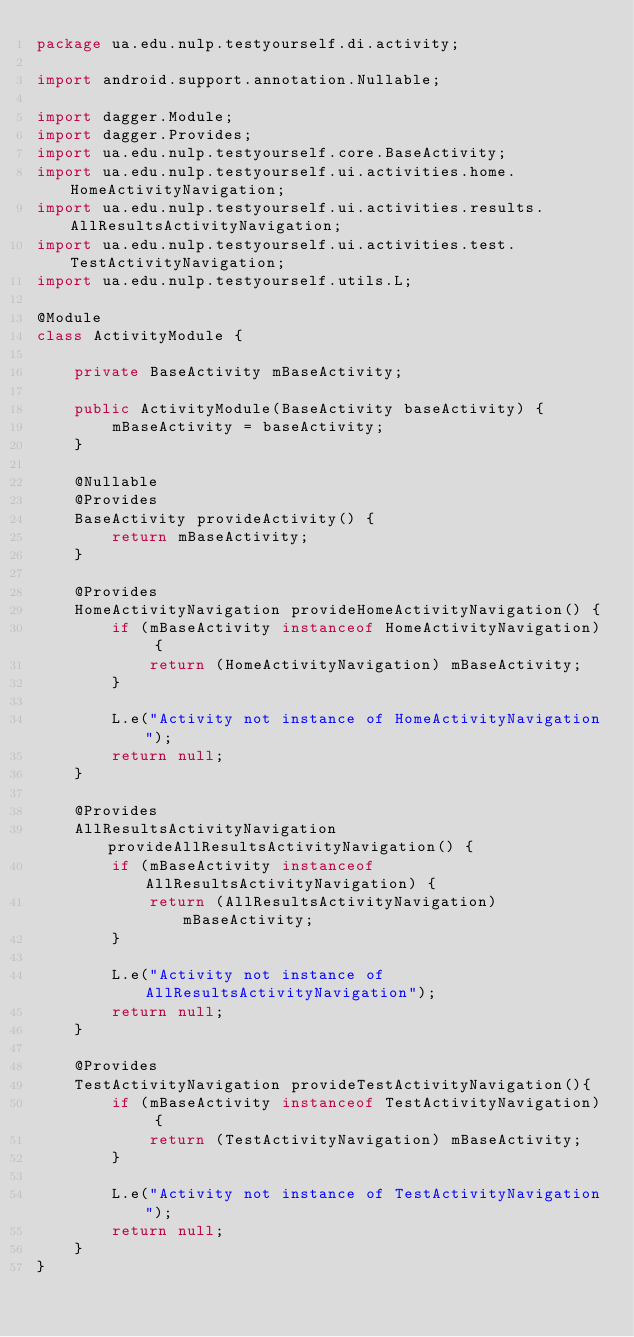Convert code to text. <code><loc_0><loc_0><loc_500><loc_500><_Java_>package ua.edu.nulp.testyourself.di.activity;

import android.support.annotation.Nullable;

import dagger.Module;
import dagger.Provides;
import ua.edu.nulp.testyourself.core.BaseActivity;
import ua.edu.nulp.testyourself.ui.activities.home.HomeActivityNavigation;
import ua.edu.nulp.testyourself.ui.activities.results.AllResultsActivityNavigation;
import ua.edu.nulp.testyourself.ui.activities.test.TestActivityNavigation;
import ua.edu.nulp.testyourself.utils.L;

@Module
class ActivityModule {

    private BaseActivity mBaseActivity;

    public ActivityModule(BaseActivity baseActivity) {
        mBaseActivity = baseActivity;
    }

    @Nullable
    @Provides
    BaseActivity provideActivity() {
        return mBaseActivity;
    }

    @Provides
    HomeActivityNavigation provideHomeActivityNavigation() {
        if (mBaseActivity instanceof HomeActivityNavigation) {
            return (HomeActivityNavigation) mBaseActivity;
        }

        L.e("Activity not instance of HomeActivityNavigation");
        return null;
    }

    @Provides
    AllResultsActivityNavigation provideAllResultsActivityNavigation() {
        if (mBaseActivity instanceof AllResultsActivityNavigation) {
            return (AllResultsActivityNavigation) mBaseActivity;
        }

        L.e("Activity not instance of AllResultsActivityNavigation");
        return null;
    }

    @Provides
    TestActivityNavigation provideTestActivityNavigation(){
        if (mBaseActivity instanceof TestActivityNavigation) {
            return (TestActivityNavigation) mBaseActivity;
        }

        L.e("Activity not instance of TestActivityNavigation");
        return null;
    }
}
</code> 